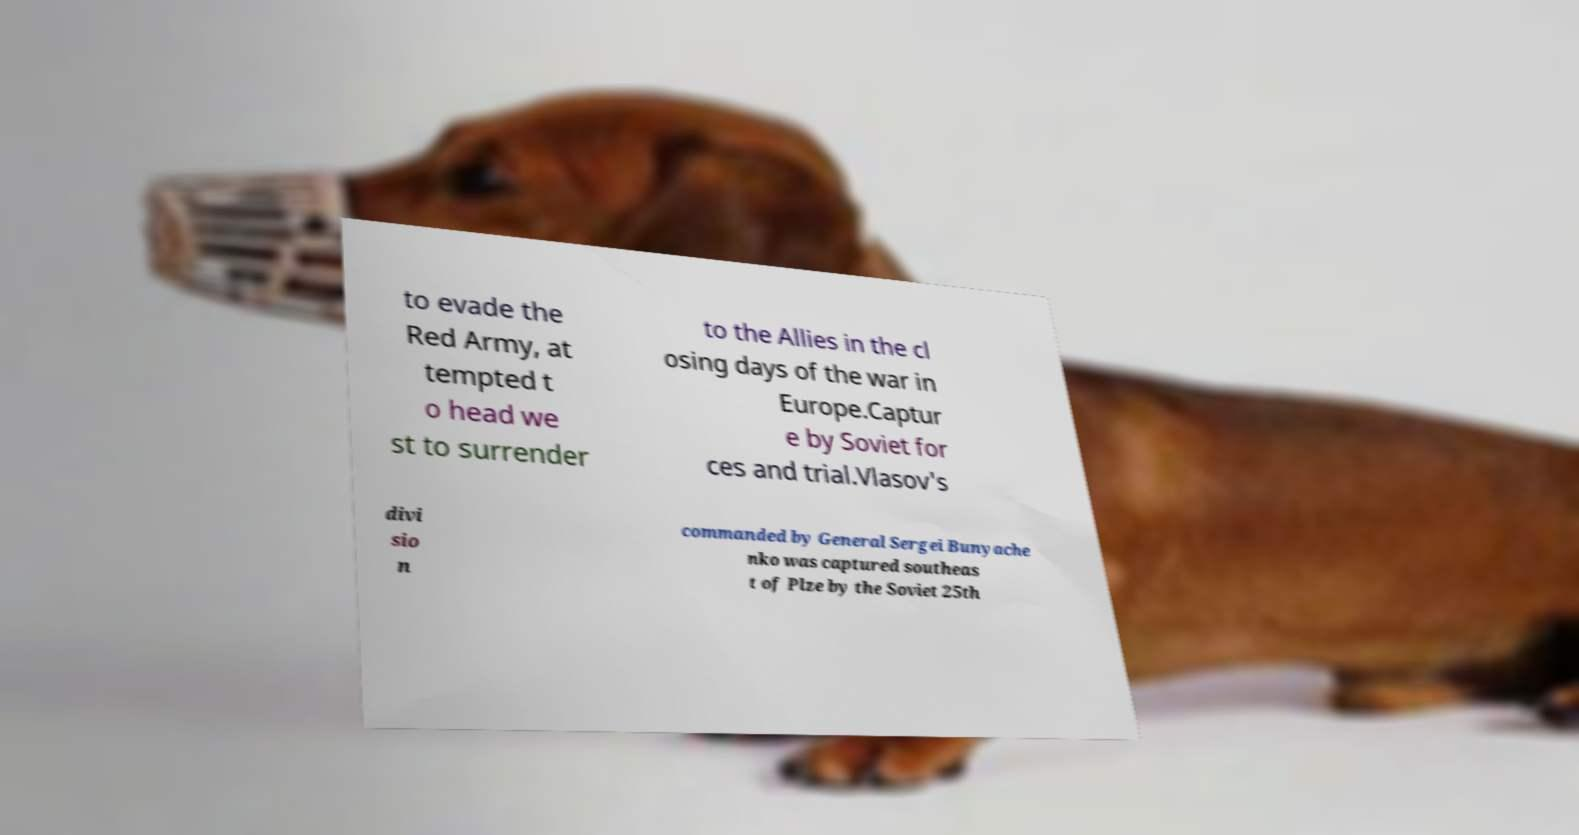Can you accurately transcribe the text from the provided image for me? to evade the Red Army, at tempted t o head we st to surrender to the Allies in the cl osing days of the war in Europe.Captur e by Soviet for ces and trial.Vlasov's divi sio n commanded by General Sergei Bunyache nko was captured southeas t of Plze by the Soviet 25th 